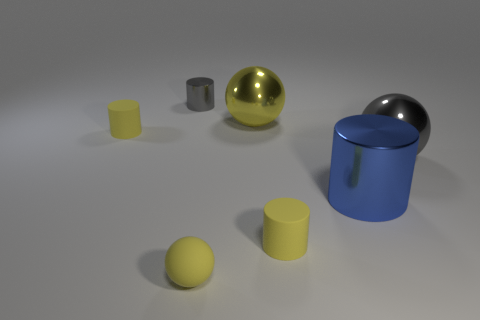Subtract all red cylinders. Subtract all yellow cubes. How many cylinders are left? 4 Add 2 big yellow shiny balls. How many objects exist? 9 Subtract all cylinders. How many objects are left? 3 Add 4 big gray metal spheres. How many big gray metal spheres exist? 5 Subtract 0 red balls. How many objects are left? 7 Subtract all cyan metal blocks. Subtract all tiny cylinders. How many objects are left? 4 Add 1 big gray objects. How many big gray objects are left? 2 